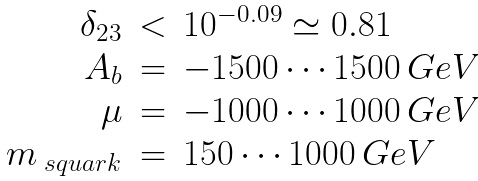Convert formula to latex. <formula><loc_0><loc_0><loc_500><loc_500>\begin{array} { r c l } \delta _ { 2 3 } & < & 1 0 ^ { - 0 . 0 9 } \simeq 0 . 8 1 \\ A _ { b } & = & - 1 5 0 0 \cdots 1 5 0 0 \ G e V \\ \mu & = & - 1 0 0 0 \cdots 1 0 0 0 \ G e V \\ m _ { \ s q u a r k } & = & 1 5 0 \cdots 1 0 0 0 \ G e V \end{array}</formula> 